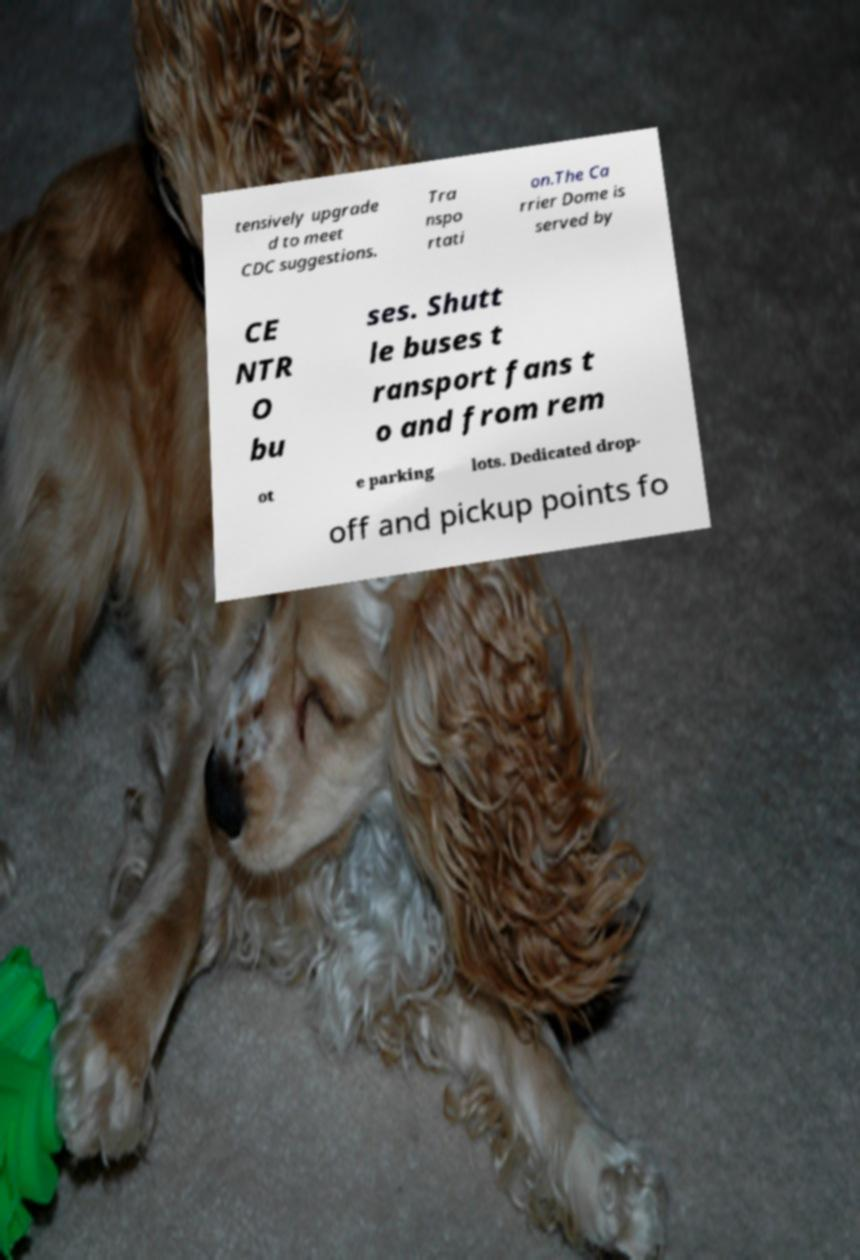There's text embedded in this image that I need extracted. Can you transcribe it verbatim? tensively upgrade d to meet CDC suggestions. Tra nspo rtati on.The Ca rrier Dome is served by CE NTR O bu ses. Shutt le buses t ransport fans t o and from rem ot e parking lots. Dedicated drop- off and pickup points fo 